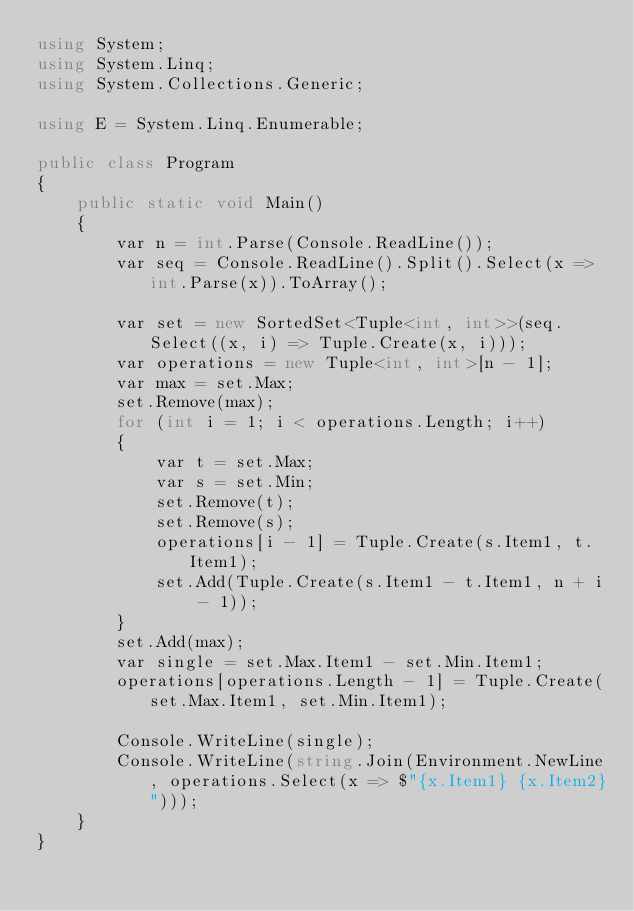Convert code to text. <code><loc_0><loc_0><loc_500><loc_500><_C#_>using System;
using System.Linq;
using System.Collections.Generic;

using E = System.Linq.Enumerable;

public class Program
{
    public static void Main()
    {
        var n = int.Parse(Console.ReadLine());
        var seq = Console.ReadLine().Split().Select(x => int.Parse(x)).ToArray();

        var set = new SortedSet<Tuple<int, int>>(seq.Select((x, i) => Tuple.Create(x, i)));
        var operations = new Tuple<int, int>[n - 1];
        var max = set.Max;
        set.Remove(max);
        for (int i = 1; i < operations.Length; i++)
        {
            var t = set.Max;
            var s = set.Min;
            set.Remove(t);
            set.Remove(s);
            operations[i - 1] = Tuple.Create(s.Item1, t.Item1);
            set.Add(Tuple.Create(s.Item1 - t.Item1, n + i - 1));
        }
        set.Add(max);
        var single = set.Max.Item1 - set.Min.Item1;
        operations[operations.Length - 1] = Tuple.Create(set.Max.Item1, set.Min.Item1);

        Console.WriteLine(single);
        Console.WriteLine(string.Join(Environment.NewLine, operations.Select(x => $"{x.Item1} {x.Item2}")));
    }
}
</code> 